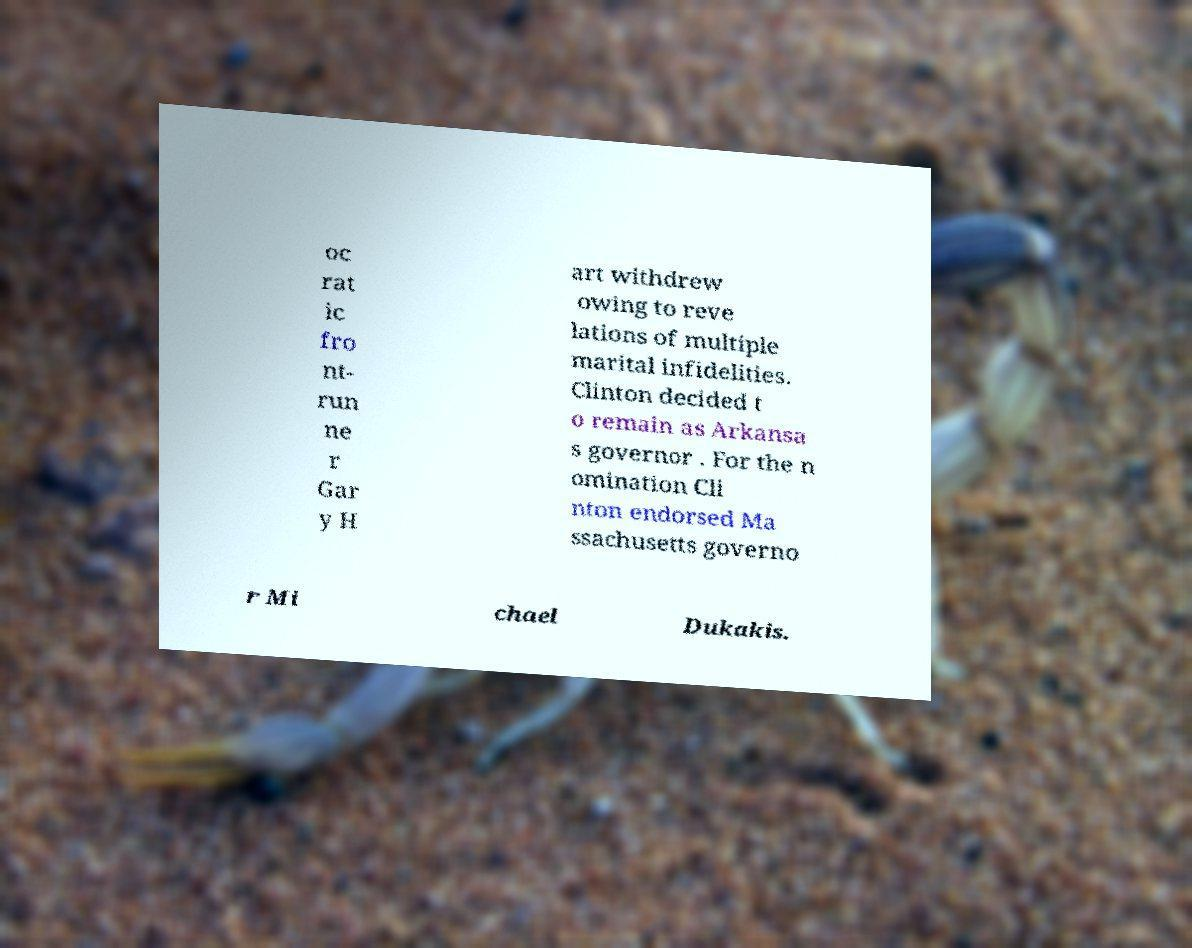Can you accurately transcribe the text from the provided image for me? oc rat ic fro nt- run ne r Gar y H art withdrew owing to reve lations of multiple marital infidelities. Clinton decided t o remain as Arkansa s governor . For the n omination Cli nton endorsed Ma ssachusetts governo r Mi chael Dukakis. 